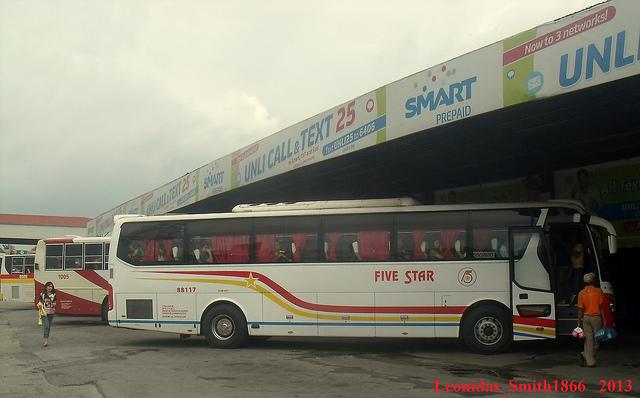Who owns the bus?
Give a very brief answer. Five star. What type of bus is shown?
Be succinct. Five star. How many buses are there?
Give a very brief answer. 3. What kind of bus is this?
Keep it brief. Charter. What color is the passenger's shirt at the front?
Write a very short answer. Orange. What color are the man on right's pants?
Be succinct. Tan. Is this a good way to see the sights?
Be succinct. Yes. Are these double decker buses?
Keep it brief. No. What city is this?
Give a very brief answer. London. How many vehicles?
Be succinct. 3. What city is the location of this picture?
Quick response, please. Mexico city. What is written on the side of the bus?
Short answer required. Five star. What color is the side of the bus?
Quick response, please. White. Is this a regular bus?
Keep it brief. Yes. 